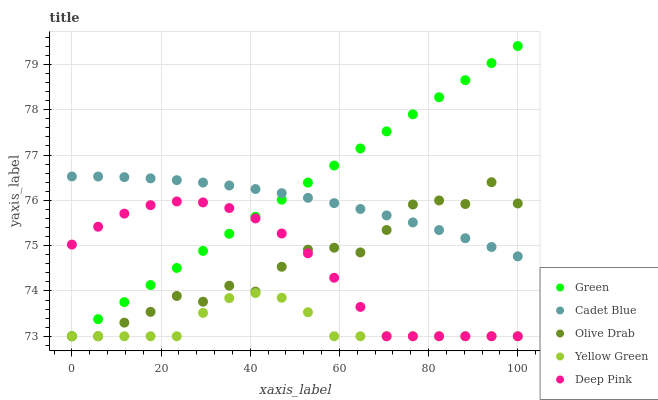Does Yellow Green have the minimum area under the curve?
Answer yes or no. Yes. Does Green have the maximum area under the curve?
Answer yes or no. Yes. Does Green have the minimum area under the curve?
Answer yes or no. No. Does Yellow Green have the maximum area under the curve?
Answer yes or no. No. Is Green the smoothest?
Answer yes or no. Yes. Is Olive Drab the roughest?
Answer yes or no. Yes. Is Yellow Green the smoothest?
Answer yes or no. No. Is Yellow Green the roughest?
Answer yes or no. No. Does Green have the lowest value?
Answer yes or no. Yes. Does Green have the highest value?
Answer yes or no. Yes. Does Yellow Green have the highest value?
Answer yes or no. No. Is Deep Pink less than Cadet Blue?
Answer yes or no. Yes. Is Cadet Blue greater than Yellow Green?
Answer yes or no. Yes. Does Olive Drab intersect Deep Pink?
Answer yes or no. Yes. Is Olive Drab less than Deep Pink?
Answer yes or no. No. Is Olive Drab greater than Deep Pink?
Answer yes or no. No. Does Deep Pink intersect Cadet Blue?
Answer yes or no. No. 